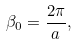<formula> <loc_0><loc_0><loc_500><loc_500>\beta _ { 0 } = \frac { 2 \pi } { a } ,</formula> 